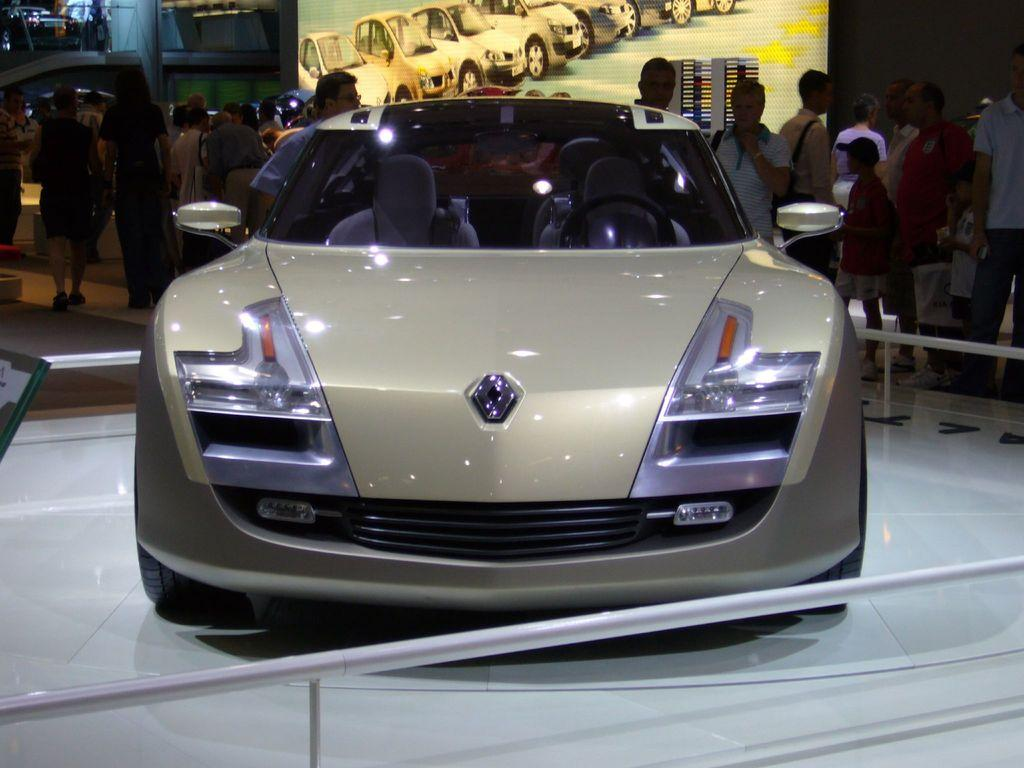What is the main subject of the image? There is a car in the image. What are the people in the image doing? The people are standing behind the car. What can be seen on the wall in the background? There is a screen on the wall in the background. What type of bean is being used as a prop in the image? There is no bean present in the image. What kind of doll is sitting on the car's hood in the image? There is no doll present on the car's hood in the image. 